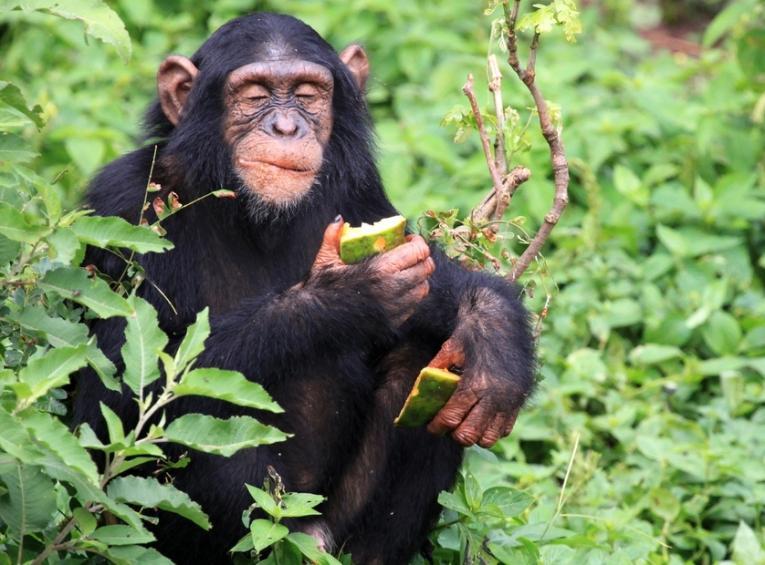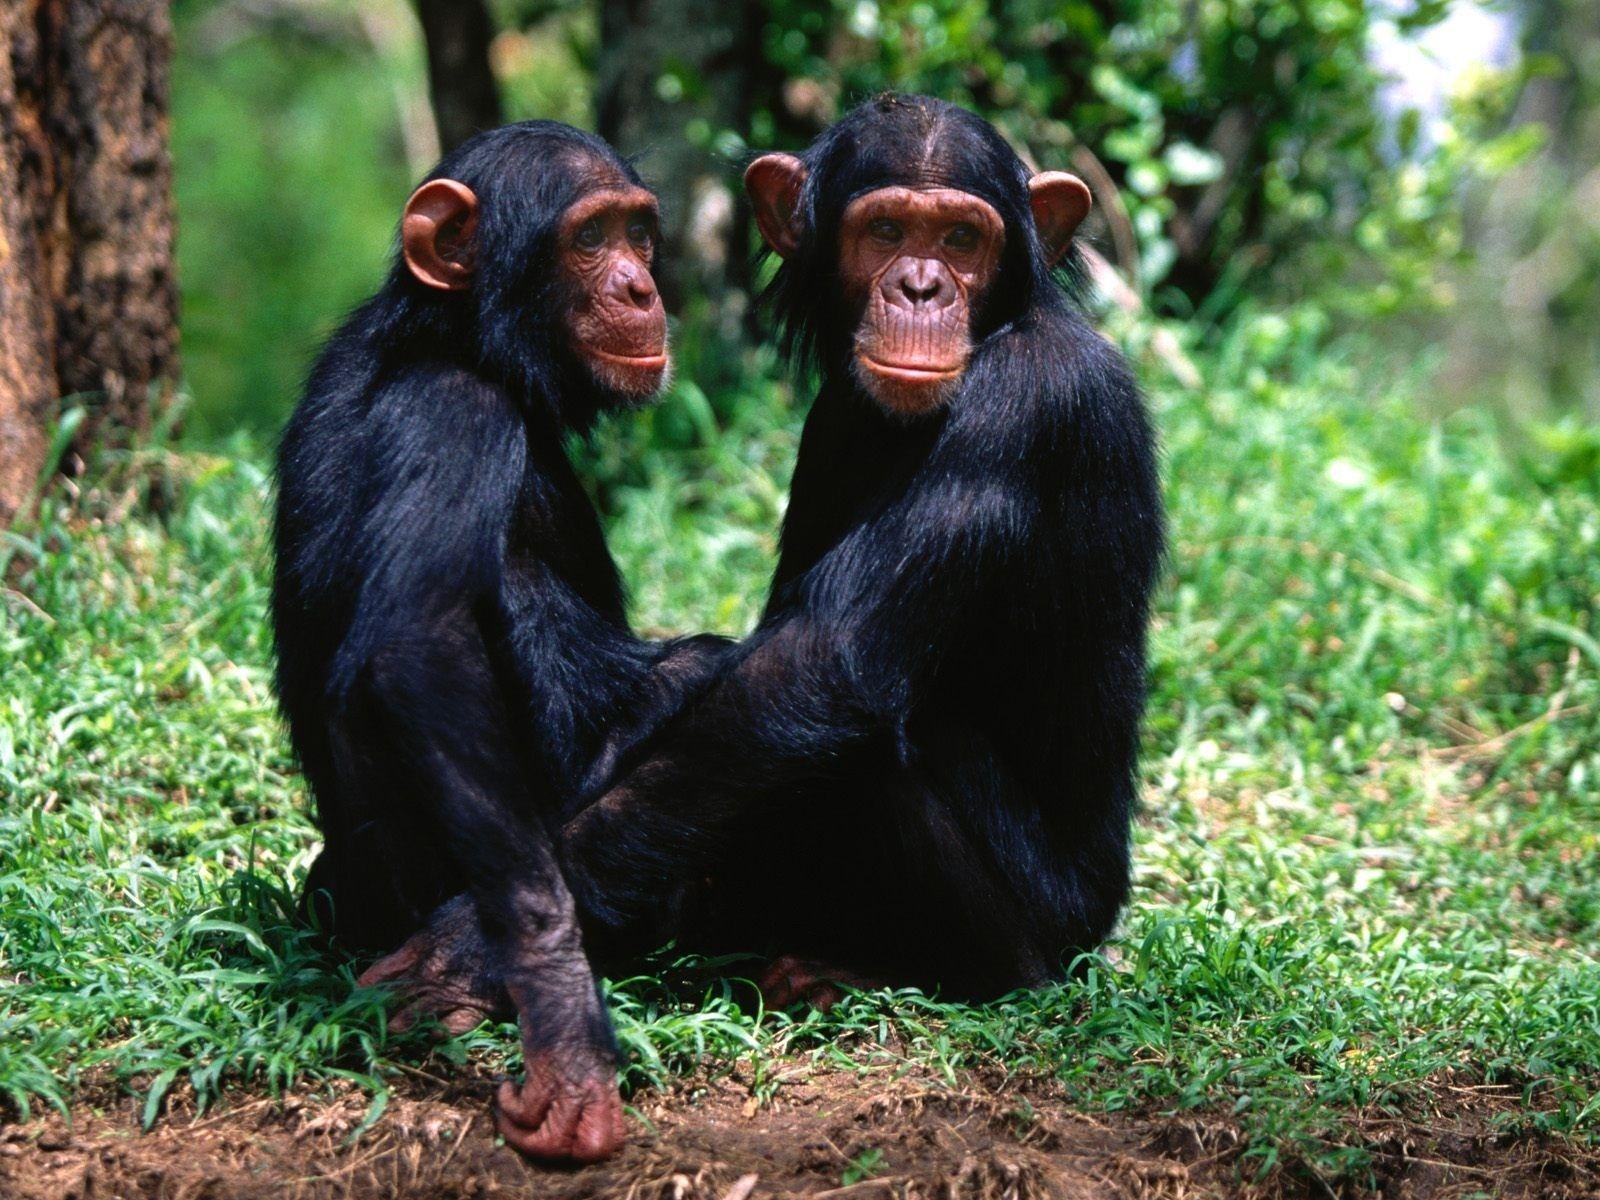The first image is the image on the left, the second image is the image on the right. Evaluate the accuracy of this statement regarding the images: "There are two monkeys in the image on the right.". Is it true? Answer yes or no. Yes. 